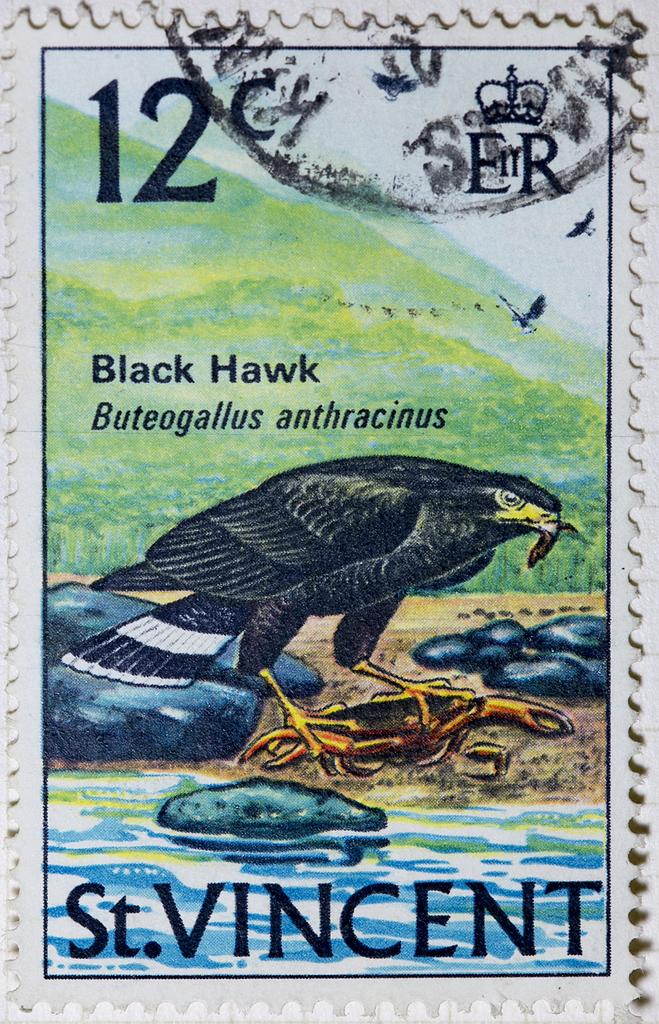What is the style of the image? The image resembles a painting. What is the main subject of the painting? There is a bird in the middle of the image. What color is the bird? The bird is black in color. What is depicted at the bottom of the image? There is water depicted at the bottom of the image. How does the image appear overall? The image has the appearance of a stamp. Can you tell me how many dogs are present in the image? There are no dogs present in the image; it features a black bird and water. 